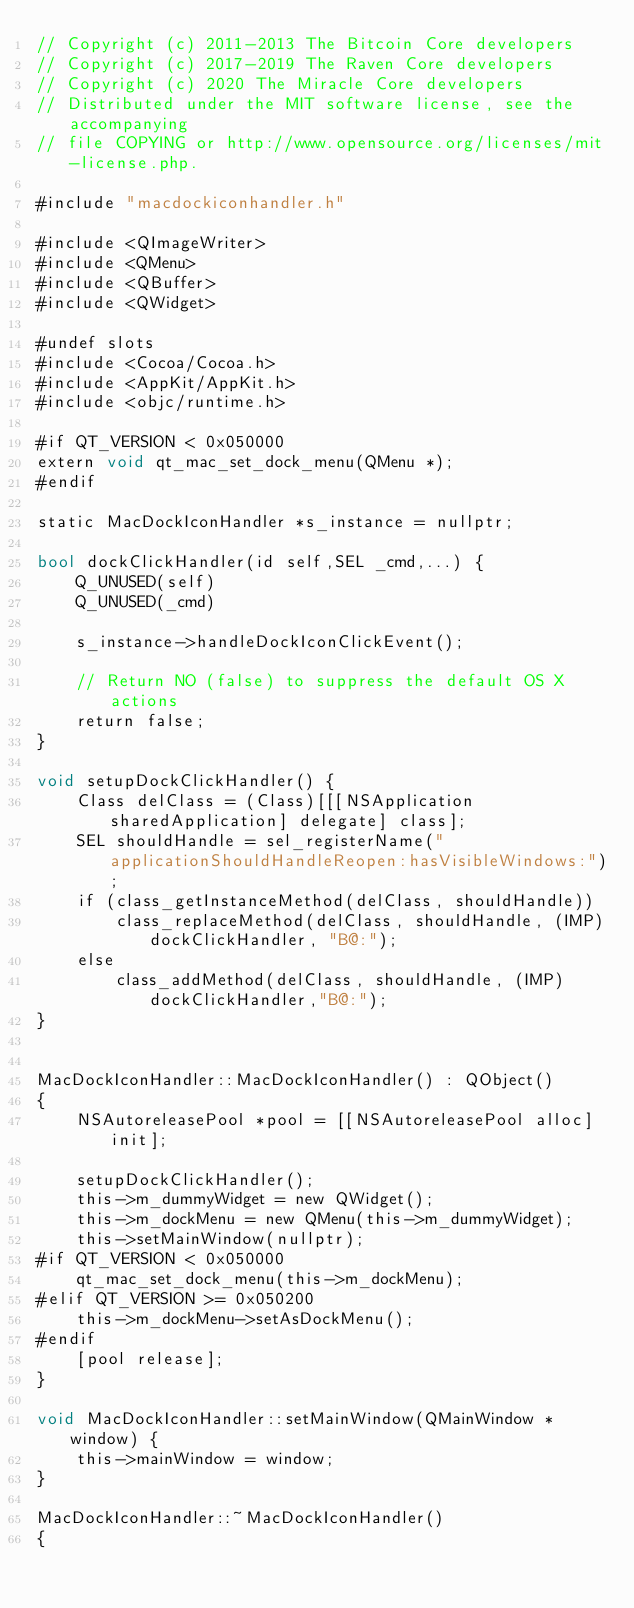<code> <loc_0><loc_0><loc_500><loc_500><_ObjectiveC_>// Copyright (c) 2011-2013 The Bitcoin Core developers
// Copyright (c) 2017-2019 The Raven Core developers
// Copyright (c) 2020 The Miracle Core developers
// Distributed under the MIT software license, see the accompanying
// file COPYING or http://www.opensource.org/licenses/mit-license.php.

#include "macdockiconhandler.h"

#include <QImageWriter>
#include <QMenu>
#include <QBuffer>
#include <QWidget>

#undef slots
#include <Cocoa/Cocoa.h>
#include <AppKit/AppKit.h>
#include <objc/runtime.h>

#if QT_VERSION < 0x050000
extern void qt_mac_set_dock_menu(QMenu *);
#endif

static MacDockIconHandler *s_instance = nullptr;

bool dockClickHandler(id self,SEL _cmd,...) {
    Q_UNUSED(self)
    Q_UNUSED(_cmd)
    
    s_instance->handleDockIconClickEvent();
    
    // Return NO (false) to suppress the default OS X actions
    return false;
}

void setupDockClickHandler() {
    Class delClass = (Class)[[[NSApplication sharedApplication] delegate] class];
    SEL shouldHandle = sel_registerName("applicationShouldHandleReopen:hasVisibleWindows:");
    if (class_getInstanceMethod(delClass, shouldHandle))
        class_replaceMethod(delClass, shouldHandle, (IMP)dockClickHandler, "B@:");
    else
        class_addMethod(delClass, shouldHandle, (IMP)dockClickHandler,"B@:");
}


MacDockIconHandler::MacDockIconHandler() : QObject()
{
    NSAutoreleasePool *pool = [[NSAutoreleasePool alloc] init];

    setupDockClickHandler();
    this->m_dummyWidget = new QWidget();
    this->m_dockMenu = new QMenu(this->m_dummyWidget);
    this->setMainWindow(nullptr);
#if QT_VERSION < 0x050000
    qt_mac_set_dock_menu(this->m_dockMenu);
#elif QT_VERSION >= 0x050200
    this->m_dockMenu->setAsDockMenu();
#endif
    [pool release];
}

void MacDockIconHandler::setMainWindow(QMainWindow *window) {
    this->mainWindow = window;
}

MacDockIconHandler::~MacDockIconHandler()
{</code> 